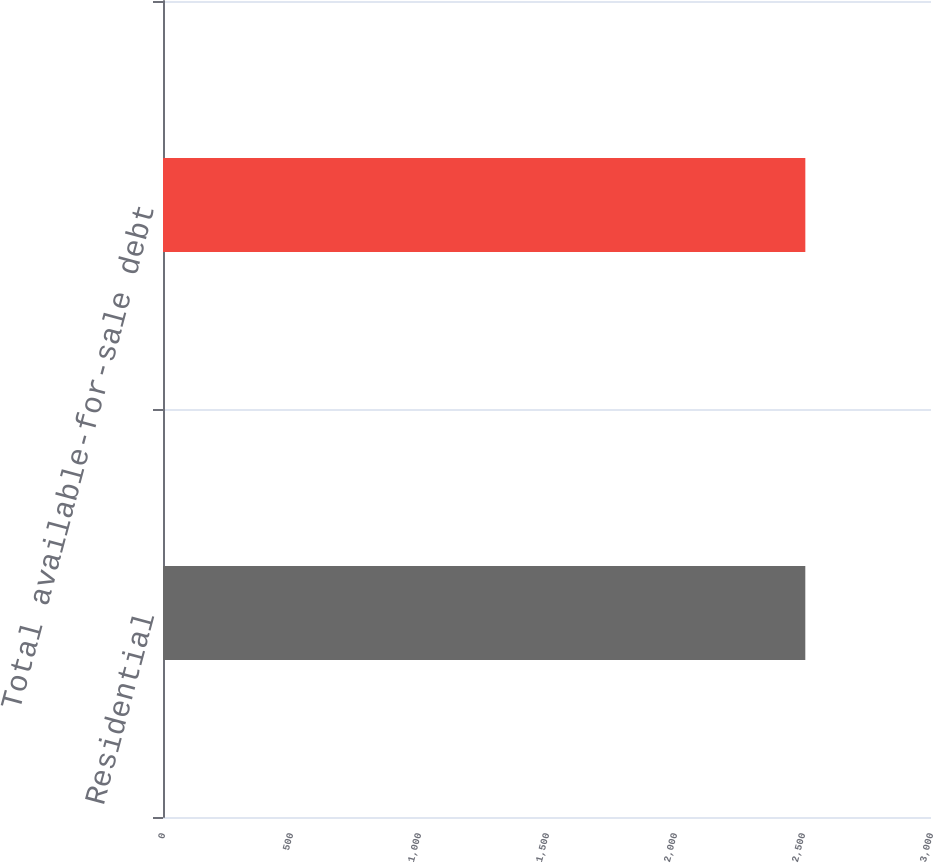<chart> <loc_0><loc_0><loc_500><loc_500><bar_chart><fcel>Residential<fcel>Total available-for-sale debt<nl><fcel>2509<fcel>2509.1<nl></chart> 